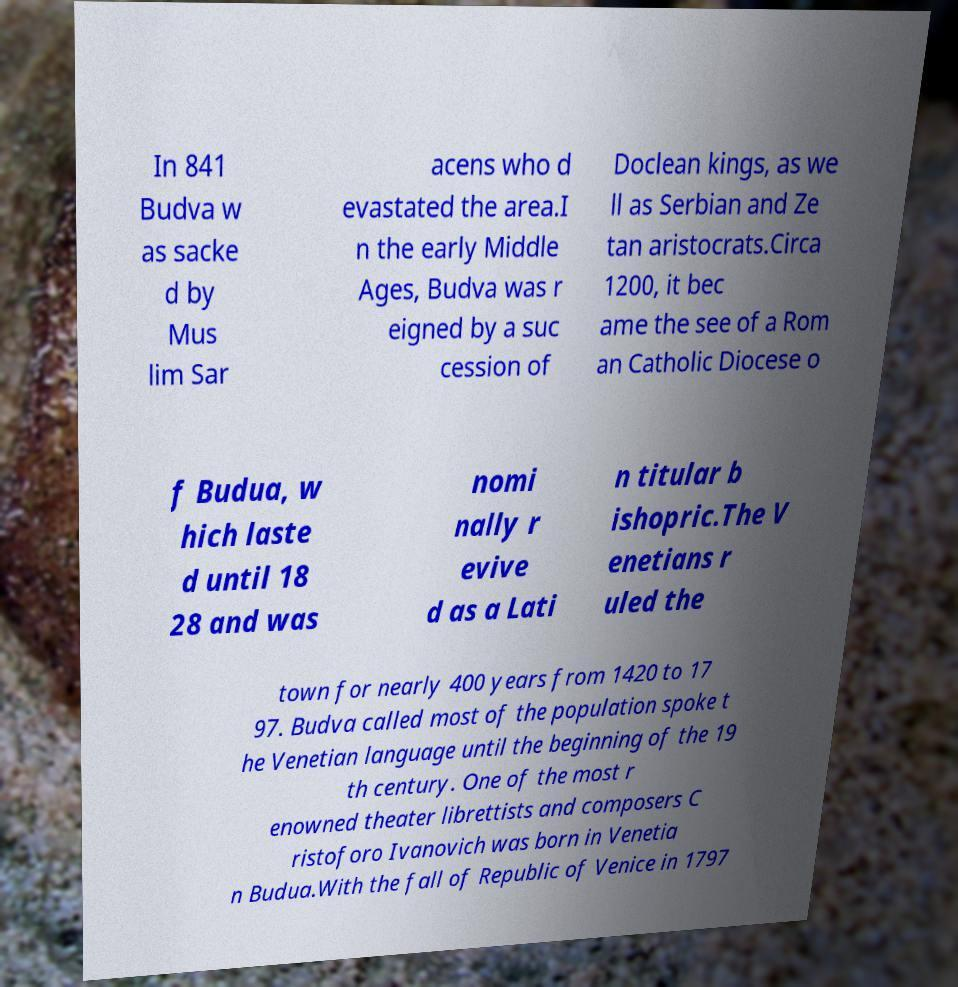Could you assist in decoding the text presented in this image and type it out clearly? In 841 Budva w as sacke d by Mus lim Sar acens who d evastated the area.I n the early Middle Ages, Budva was r eigned by a suc cession of Doclean kings, as we ll as Serbian and Ze tan aristocrats.Circa 1200, it bec ame the see of a Rom an Catholic Diocese o f Budua, w hich laste d until 18 28 and was nomi nally r evive d as a Lati n titular b ishopric.The V enetians r uled the town for nearly 400 years from 1420 to 17 97. Budva called most of the population spoke t he Venetian language until the beginning of the 19 th century. One of the most r enowned theater librettists and composers C ristoforo Ivanovich was born in Venetia n Budua.With the fall of Republic of Venice in 1797 